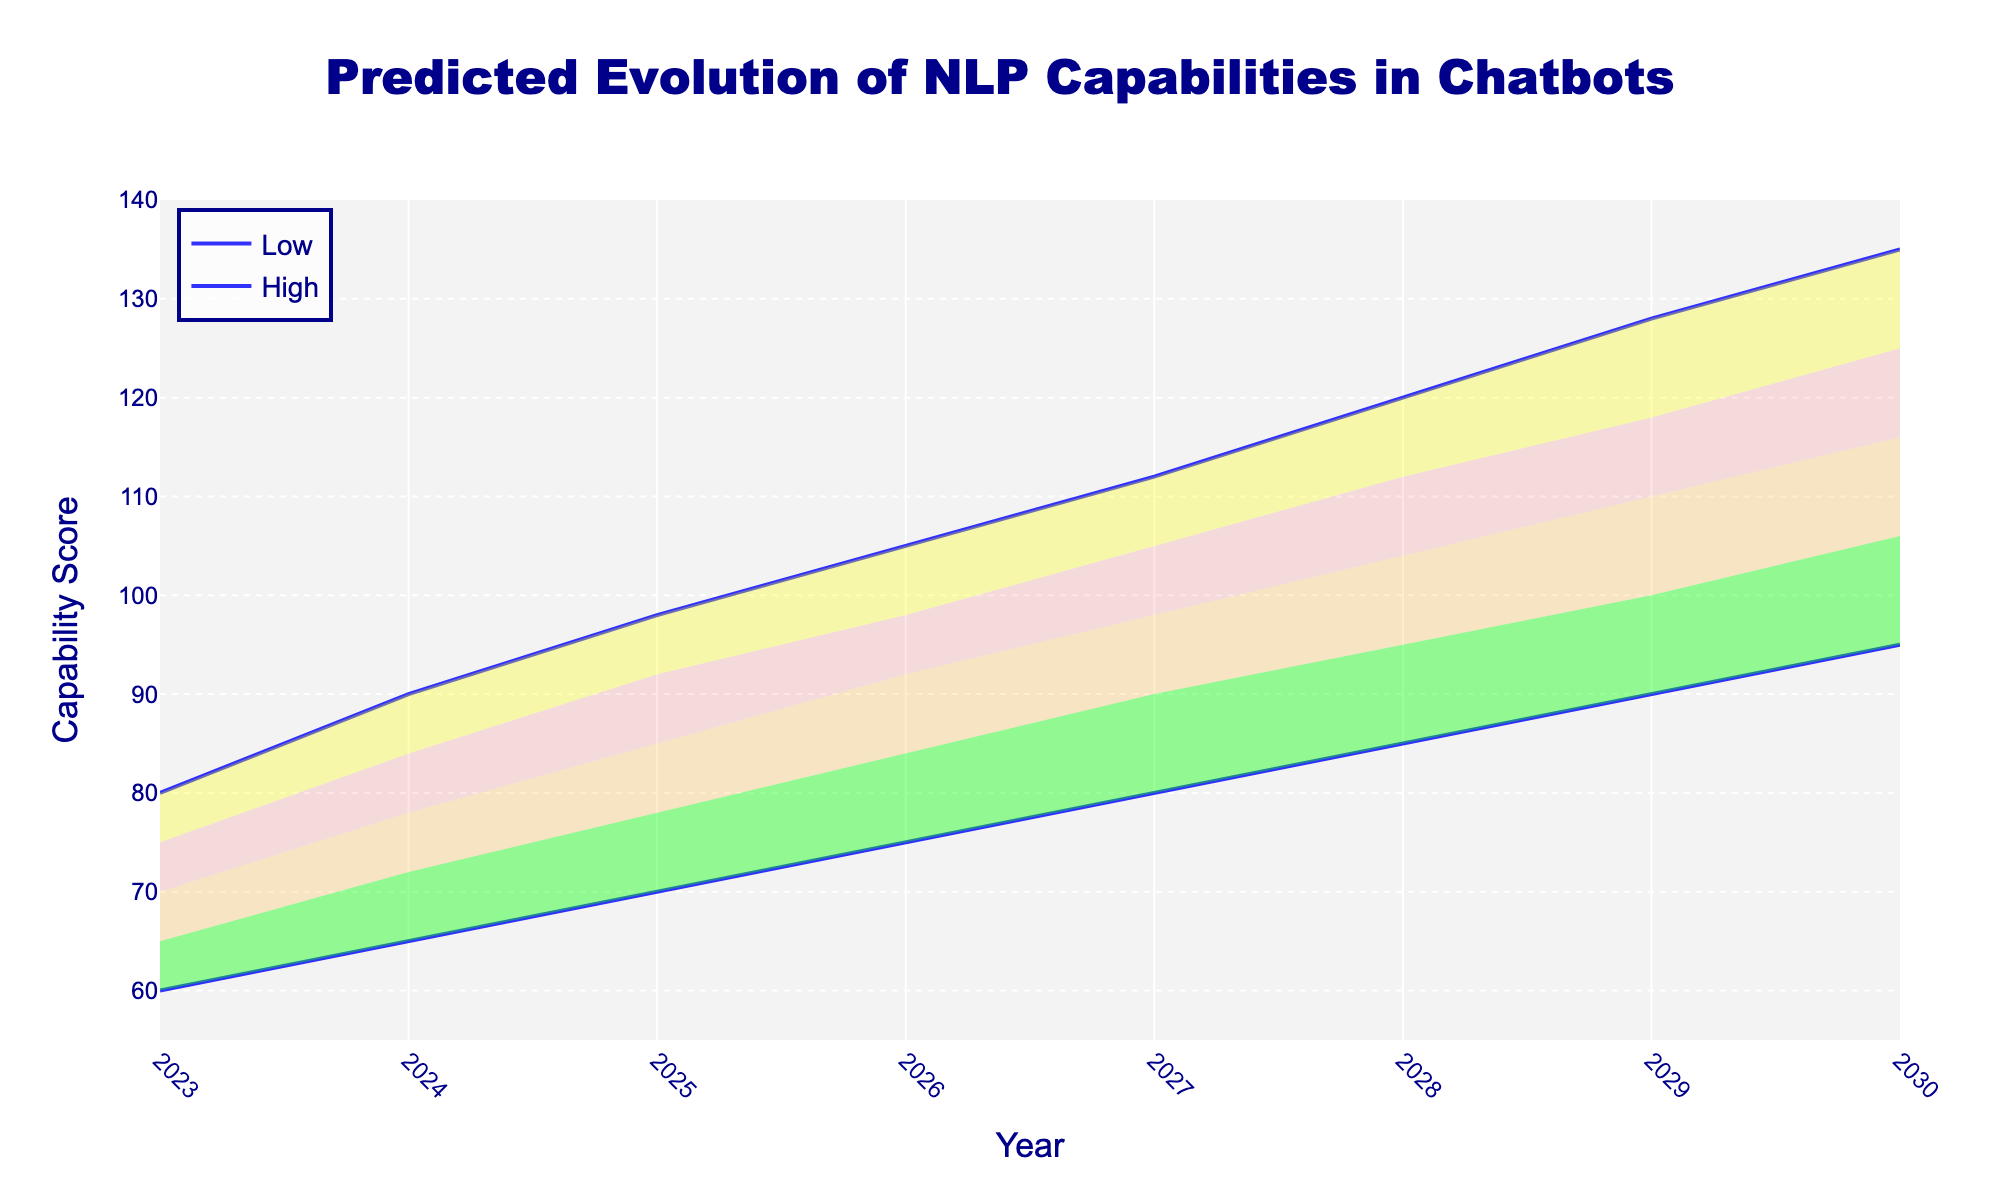What is the title of the chart? The title is displayed prominently at the top center of the chart, mentioning the main topic of the figure.
Answer: Predicted Evolution of NLP Capabilities in Chatbots What does the y-axis represent? The y-axis label is indicated on the vertical axis of the chart.
Answer: Capability Score Between which years does the chart predict the evolution? The x-axis starts from 2023 and ends at 2030.
Answer: 2023 to 2030 How does the lowest predicted capability score change from 2023 to 2030? Observe the line corresponding to "Low" from 2023 to 2030, noting the values at both endpoints.
Answer: It increases from 60 to 95 By how many units is the high capability score in 2025 higher than the low score in the same year? Look at the scores for the "High" and "Low" lines for the year 2025, subtracting the low value from the high value.
Answer: 28 units What is the predicted range of mid-high capability scores in 2027? Check the values for "Mid-High" in the year 2027, which lies within Q3 of the confidence bands.
Answer: 105 Which year shows the widest range in the confidence bands from low to high? To determine the largest range, find the difference between "High" and "Low" for each year, and then identify the year with the maximum difference.
Answer: 2029 When is the expected average capability at its highest? The mid-value represents the average capability, and by checking the "Mid" values, we can identify the year with the highest value.
Answer: 2030 In 2026, what are the lower and upper bounds of the mid-level predictions? Identify the values for "Low-Mid" and "Mid-High" in the year 2026.
Answer: 84 and 98 Which color represents the highest confidence band? Examine the legend and the filled regions to deduce the color corresponding to the highest confidence band.
Answer: Light red 